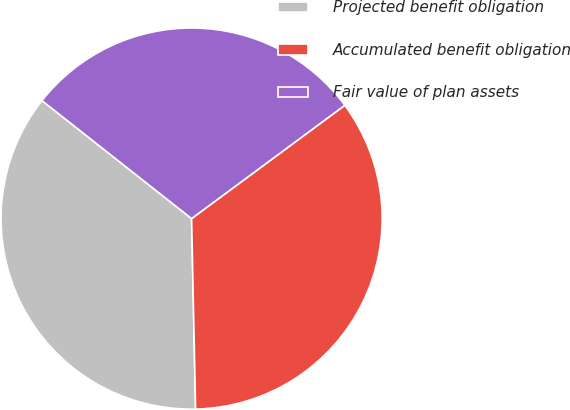Convert chart to OTSL. <chart><loc_0><loc_0><loc_500><loc_500><pie_chart><fcel>Projected benefit obligation<fcel>Accumulated benefit obligation<fcel>Fair value of plan assets<nl><fcel>35.96%<fcel>34.8%<fcel>29.24%<nl></chart> 